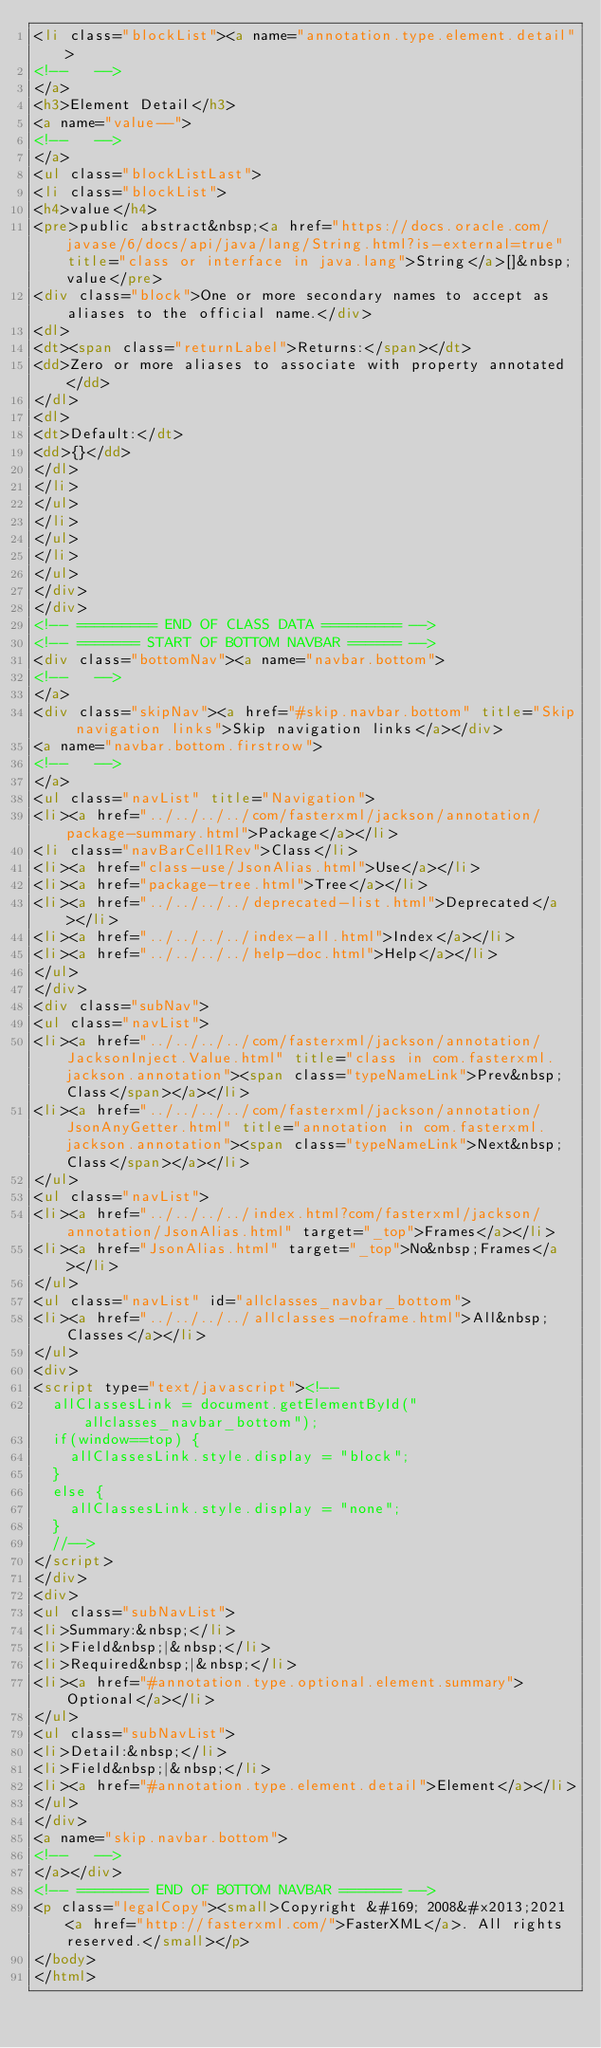Convert code to text. <code><loc_0><loc_0><loc_500><loc_500><_HTML_><li class="blockList"><a name="annotation.type.element.detail">
<!--   -->
</a>
<h3>Element Detail</h3>
<a name="value--">
<!--   -->
</a>
<ul class="blockListLast">
<li class="blockList">
<h4>value</h4>
<pre>public abstract&nbsp;<a href="https://docs.oracle.com/javase/6/docs/api/java/lang/String.html?is-external=true" title="class or interface in java.lang">String</a>[]&nbsp;value</pre>
<div class="block">One or more secondary names to accept as aliases to the official name.</div>
<dl>
<dt><span class="returnLabel">Returns:</span></dt>
<dd>Zero or more aliases to associate with property annotated</dd>
</dl>
<dl>
<dt>Default:</dt>
<dd>{}</dd>
</dl>
</li>
</ul>
</li>
</ul>
</li>
</ul>
</div>
</div>
<!-- ========= END OF CLASS DATA ========= -->
<!-- ======= START OF BOTTOM NAVBAR ====== -->
<div class="bottomNav"><a name="navbar.bottom">
<!--   -->
</a>
<div class="skipNav"><a href="#skip.navbar.bottom" title="Skip navigation links">Skip navigation links</a></div>
<a name="navbar.bottom.firstrow">
<!--   -->
</a>
<ul class="navList" title="Navigation">
<li><a href="../../../../com/fasterxml/jackson/annotation/package-summary.html">Package</a></li>
<li class="navBarCell1Rev">Class</li>
<li><a href="class-use/JsonAlias.html">Use</a></li>
<li><a href="package-tree.html">Tree</a></li>
<li><a href="../../../../deprecated-list.html">Deprecated</a></li>
<li><a href="../../../../index-all.html">Index</a></li>
<li><a href="../../../../help-doc.html">Help</a></li>
</ul>
</div>
<div class="subNav">
<ul class="navList">
<li><a href="../../../../com/fasterxml/jackson/annotation/JacksonInject.Value.html" title="class in com.fasterxml.jackson.annotation"><span class="typeNameLink">Prev&nbsp;Class</span></a></li>
<li><a href="../../../../com/fasterxml/jackson/annotation/JsonAnyGetter.html" title="annotation in com.fasterxml.jackson.annotation"><span class="typeNameLink">Next&nbsp;Class</span></a></li>
</ul>
<ul class="navList">
<li><a href="../../../../index.html?com/fasterxml/jackson/annotation/JsonAlias.html" target="_top">Frames</a></li>
<li><a href="JsonAlias.html" target="_top">No&nbsp;Frames</a></li>
</ul>
<ul class="navList" id="allclasses_navbar_bottom">
<li><a href="../../../../allclasses-noframe.html">All&nbsp;Classes</a></li>
</ul>
<div>
<script type="text/javascript"><!--
  allClassesLink = document.getElementById("allclasses_navbar_bottom");
  if(window==top) {
    allClassesLink.style.display = "block";
  }
  else {
    allClassesLink.style.display = "none";
  }
  //-->
</script>
</div>
<div>
<ul class="subNavList">
<li>Summary:&nbsp;</li>
<li>Field&nbsp;|&nbsp;</li>
<li>Required&nbsp;|&nbsp;</li>
<li><a href="#annotation.type.optional.element.summary">Optional</a></li>
</ul>
<ul class="subNavList">
<li>Detail:&nbsp;</li>
<li>Field&nbsp;|&nbsp;</li>
<li><a href="#annotation.type.element.detail">Element</a></li>
</ul>
</div>
<a name="skip.navbar.bottom">
<!--   -->
</a></div>
<!-- ======== END OF BOTTOM NAVBAR ======= -->
<p class="legalCopy"><small>Copyright &#169; 2008&#x2013;2021 <a href="http://fasterxml.com/">FasterXML</a>. All rights reserved.</small></p>
</body>
</html>
</code> 